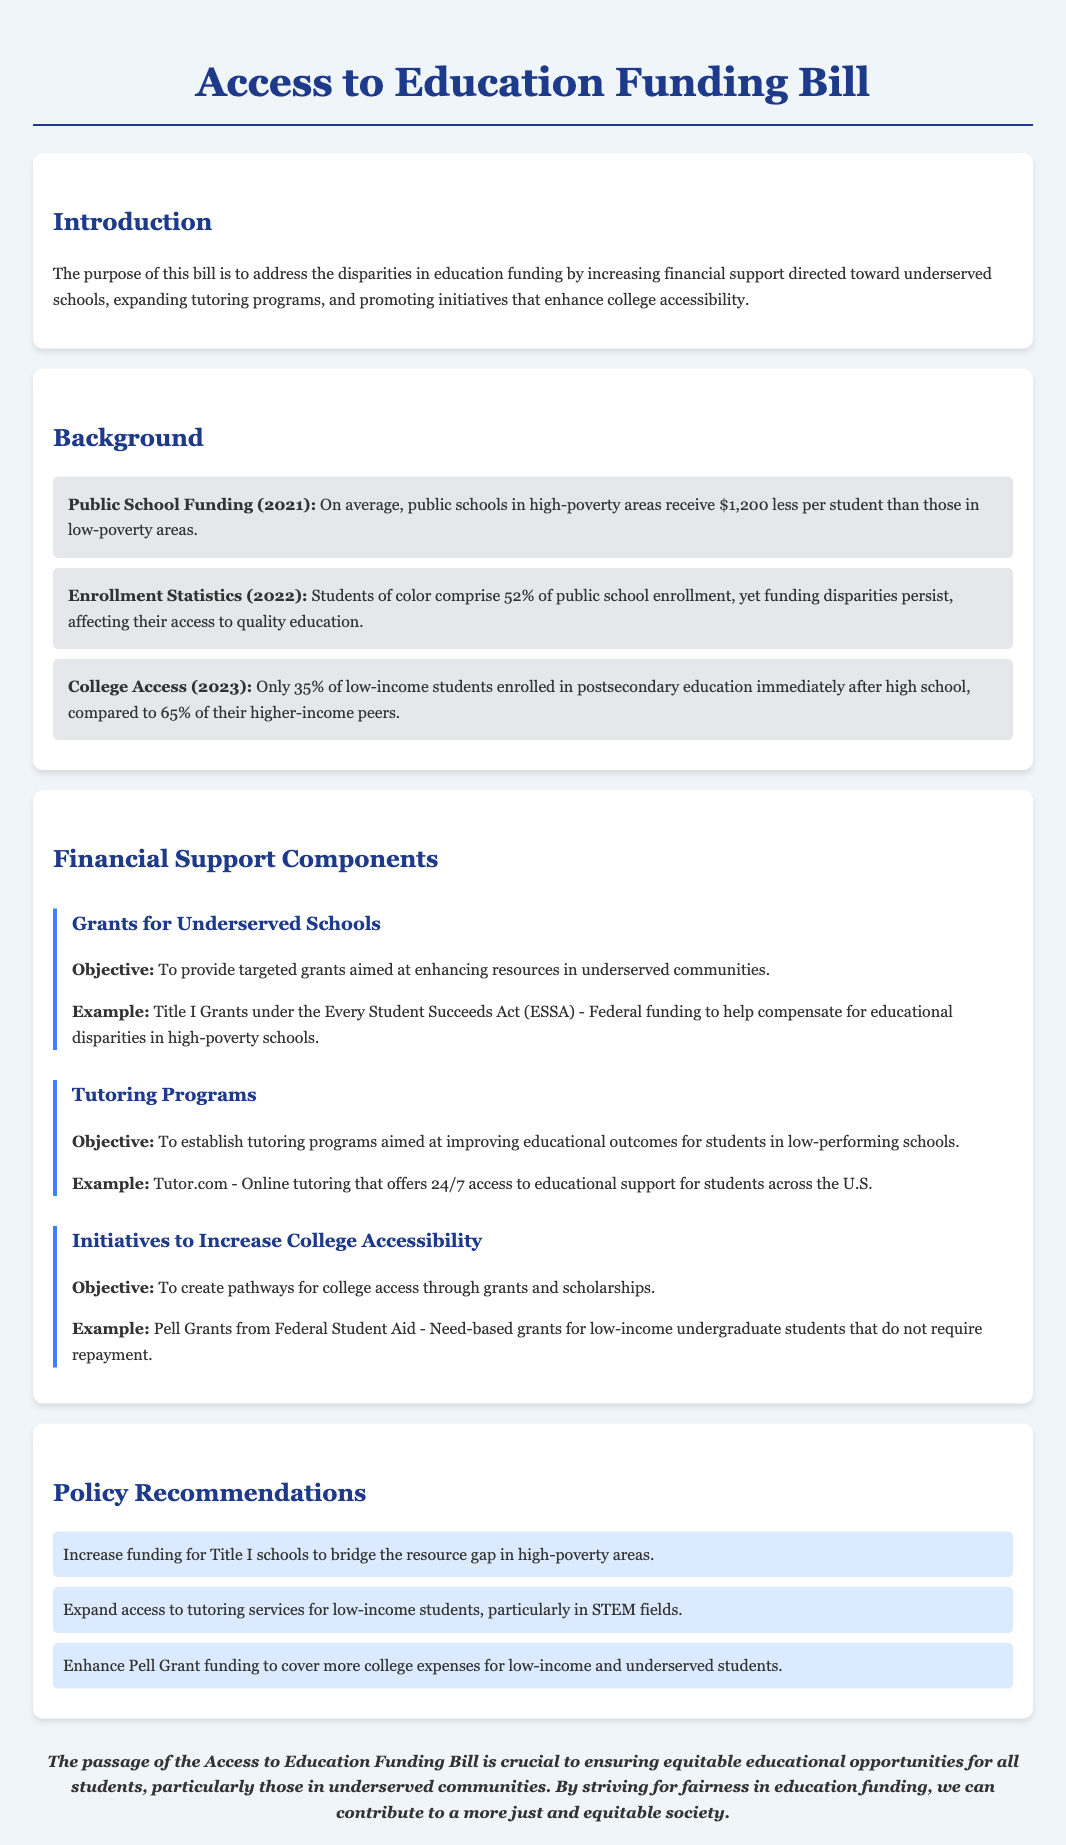What is the average funding gap for public schools in high-poverty areas? The document states that on average, public schools in high-poverty areas receive $1,200 less per student than those in low-poverty areas.
Answer: $1,200 What percentage of students of color comprise public school enrollment? According to the document, students of color comprise 52% of public school enrollment.
Answer: 52% What is the percentage of low-income students who enrolled in postsecondary education immediately after high school? The document mentions that only 35% of low-income students enrolled in postsecondary education immediately after high school.
Answer: 35% What is the objective of grants for underserved schools? The document outlines that the objective is to provide targeted grants aimed at enhancing resources in underserved communities.
Answer: Enhance resources What is an example of a need-based grant mentioned in the bill? The document provides Pell Grants from Federal Student Aid as an example of need-based grants for low-income undergraduate students.
Answer: Pell Grants What recommendation is made regarding Title I schools? The document recommends increasing funding for Title I schools to bridge the resource gap in high-poverty areas.
Answer: Increase funding What is the aim of the tutoring programs mentioned in the bill? The document states that the aim is to establish tutoring programs aimed at improving educational outcomes for students in low-performing schools.
Answer: Improve outcomes What initiative is proposed to enhance college accessibility? The document mentions creating pathways for college access through grants and scholarships.
Answer: Grants and scholarships 